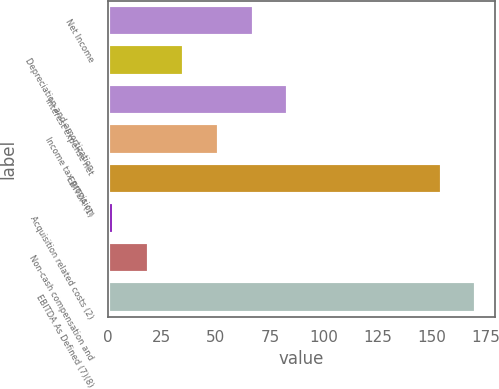Convert chart to OTSL. <chart><loc_0><loc_0><loc_500><loc_500><bar_chart><fcel>Net Income<fcel>Depreciation and amortization<fcel>Interest expense net<fcel>Income tax provision<fcel>EBITDA (1)<fcel>Acquisition related costs (2)<fcel>Non-cash compensation and<fcel>EBITDA As Defined (7)(8)<nl><fcel>67.42<fcel>35.16<fcel>83.55<fcel>51.29<fcel>154.5<fcel>2.9<fcel>19.03<fcel>170.63<nl></chart> 